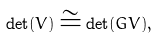<formula> <loc_0><loc_0><loc_500><loc_500>\det ( V ) \cong \det ( G V ) ,</formula> 